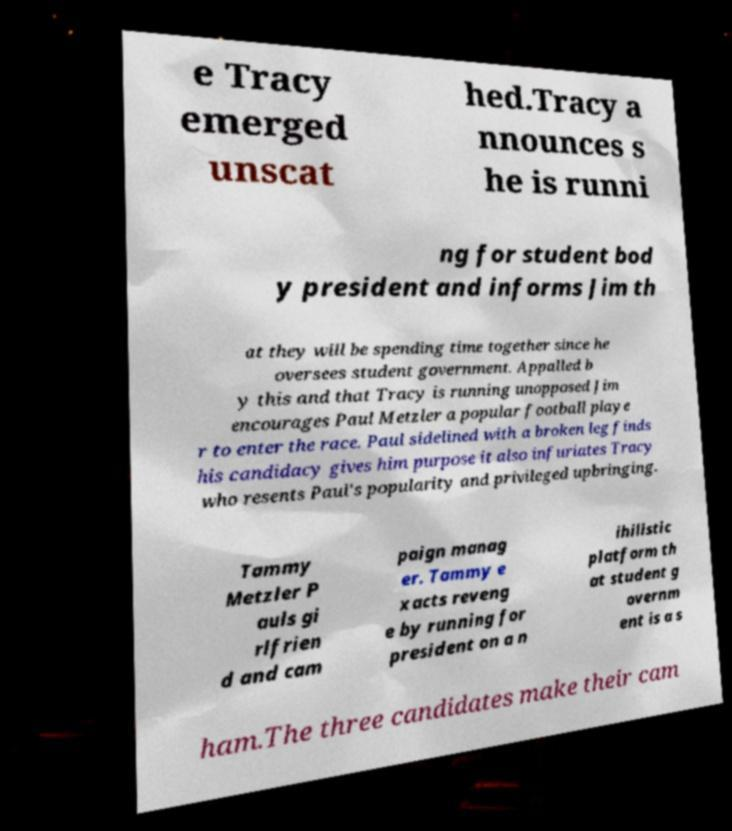Could you assist in decoding the text presented in this image and type it out clearly? e Tracy emerged unscat hed.Tracy a nnounces s he is runni ng for student bod y president and informs Jim th at they will be spending time together since he oversees student government. Appalled b y this and that Tracy is running unopposed Jim encourages Paul Metzler a popular football playe r to enter the race. Paul sidelined with a broken leg finds his candidacy gives him purpose it also infuriates Tracy who resents Paul's popularity and privileged upbringing. Tammy Metzler P auls gi rlfrien d and cam paign manag er. Tammy e xacts reveng e by running for president on a n ihilistic platform th at student g overnm ent is a s ham.The three candidates make their cam 